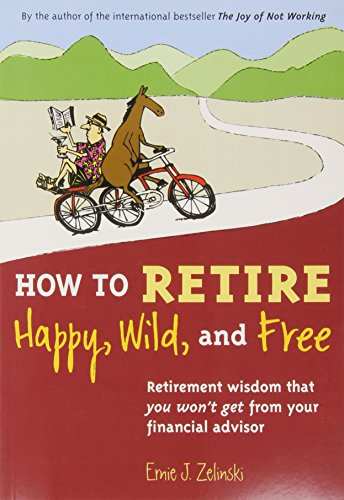How does the cover art of the book relate to its content? The cover art, featuring a relaxed individual reading while riding a tandem bicycle with a dog, symbolizes the adventurous and carefree spirit that the book promotes for retirement. 